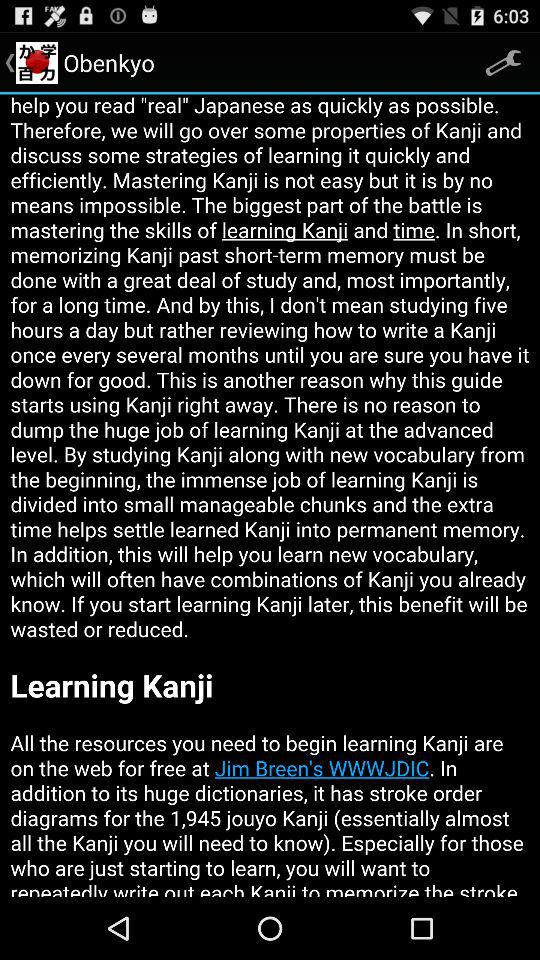What is the name of the learning subject? The name is "Kanji". 